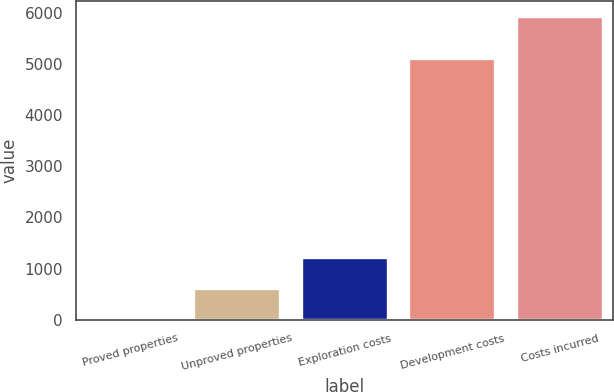<chart> <loc_0><loc_0><loc_500><loc_500><bar_chart><fcel>Proved properties<fcel>Unproved properties<fcel>Exploration costs<fcel>Development costs<fcel>Costs incurred<nl><fcel>22<fcel>612<fcel>1202<fcel>5089<fcel>5922<nl></chart> 